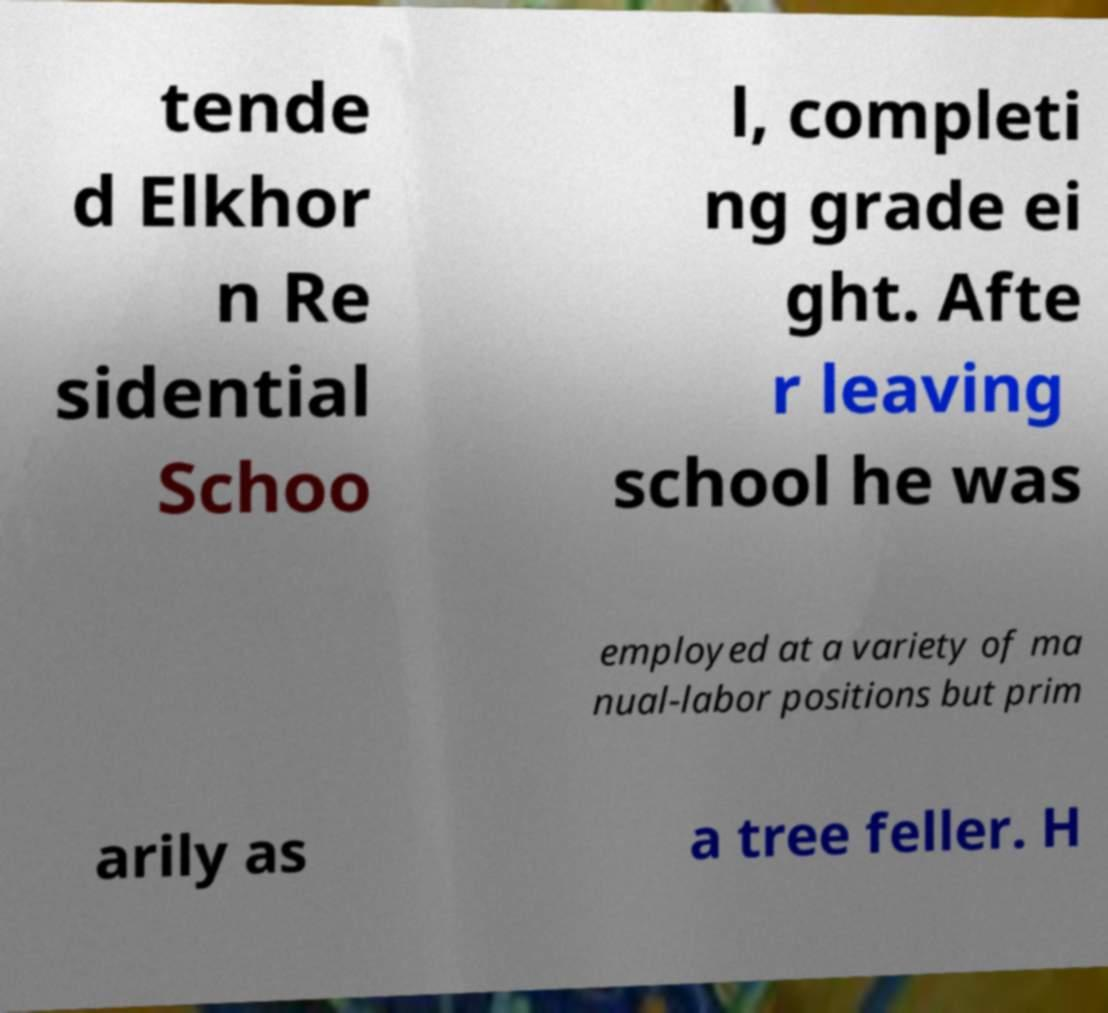For documentation purposes, I need the text within this image transcribed. Could you provide that? tende d Elkhor n Re sidential Schoo l, completi ng grade ei ght. Afte r leaving school he was employed at a variety of ma nual-labor positions but prim arily as a tree feller. H 